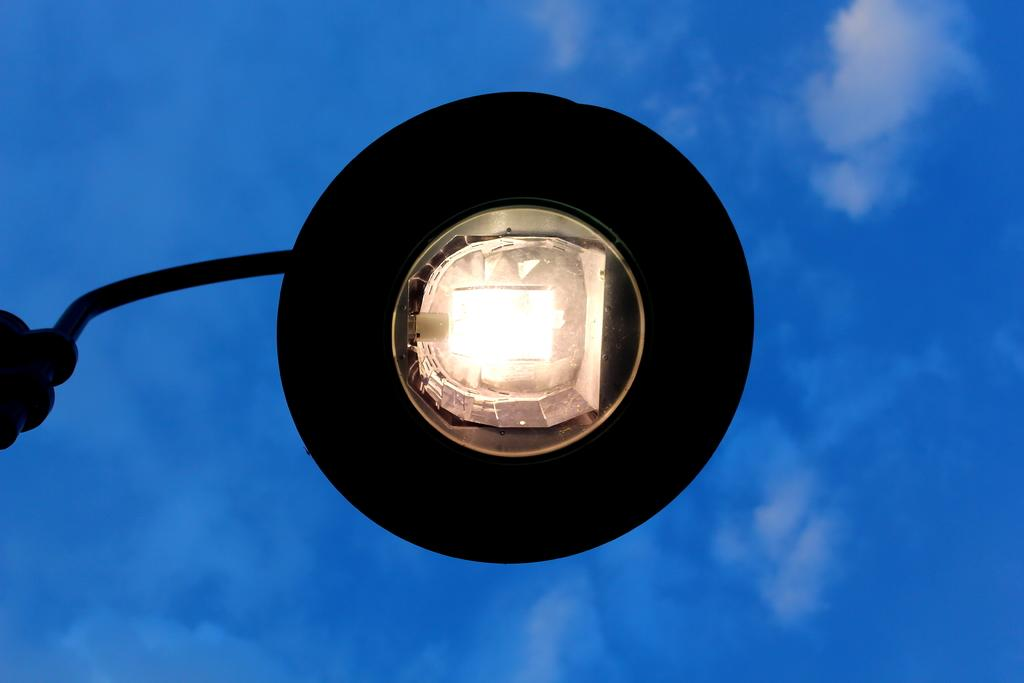What type of structure is present in the image? There is a street light in the image. What other object can be seen in the image? There is a rod in the image. How would you describe the sky in the image? The sky is blue and cloudy in the image. How many clocks are hanging from the street light in the image? There are no clocks present in the image; it only features a street light and a rod. What type of doll is sitting on the rod in the image? There is no doll present on the rod or anywhere else in the image. 